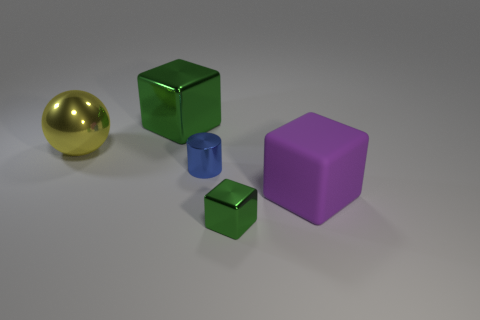How many other objects are the same size as the blue metallic object?
Offer a terse response. 1. What material is the big cube that is in front of the large metallic thing that is on the left side of the green block behind the big yellow metallic thing made of?
Offer a very short reply. Rubber. What number of cubes are either rubber objects or green metal things?
Offer a very short reply. 3. Are there any other things that are the same shape as the big yellow shiny object?
Provide a succinct answer. No. Are there more large green metallic objects on the left side of the large shiny cube than large green shiny objects that are on the right side of the big purple thing?
Your response must be concise. No. There is a metallic cube that is behind the small blue cylinder; what number of large green metal objects are to the right of it?
Make the answer very short. 0. How many things are cyan shiny objects or large yellow balls?
Your answer should be compact. 1. Is the yellow metallic object the same shape as the large rubber thing?
Ensure brevity in your answer.  No. What material is the big purple object?
Your response must be concise. Rubber. How many objects are in front of the metallic ball and behind the tiny green shiny thing?
Your answer should be very brief. 2. 